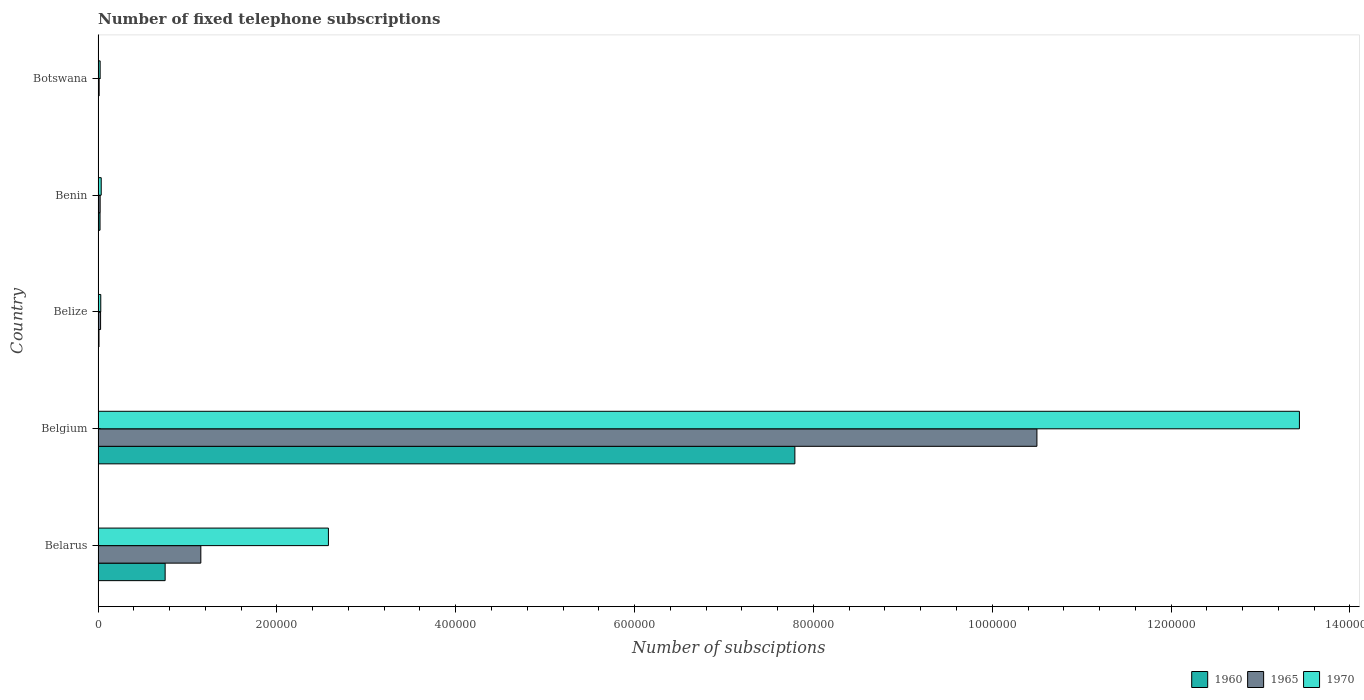What is the label of the 1st group of bars from the top?
Your answer should be very brief. Botswana. In how many cases, is the number of bars for a given country not equal to the number of legend labels?
Make the answer very short. 0. Across all countries, what is the maximum number of fixed telephone subscriptions in 1960?
Offer a very short reply. 7.79e+05. Across all countries, what is the minimum number of fixed telephone subscriptions in 1960?
Make the answer very short. 400. In which country was the number of fixed telephone subscriptions in 1970 minimum?
Give a very brief answer. Botswana. What is the total number of fixed telephone subscriptions in 1960 in the graph?
Give a very brief answer. 8.58e+05. What is the difference between the number of fixed telephone subscriptions in 1965 in Belarus and that in Belize?
Your answer should be very brief. 1.12e+05. What is the average number of fixed telephone subscriptions in 1960 per country?
Provide a succinct answer. 1.72e+05. What is the difference between the number of fixed telephone subscriptions in 1970 and number of fixed telephone subscriptions in 1965 in Belarus?
Your answer should be compact. 1.43e+05. In how many countries, is the number of fixed telephone subscriptions in 1965 greater than 360000 ?
Offer a very short reply. 1. What is the ratio of the number of fixed telephone subscriptions in 1970 in Belgium to that in Botswana?
Ensure brevity in your answer.  584.15. What is the difference between the highest and the second highest number of fixed telephone subscriptions in 1965?
Provide a short and direct response. 9.35e+05. What is the difference between the highest and the lowest number of fixed telephone subscriptions in 1970?
Your answer should be compact. 1.34e+06. Is the sum of the number of fixed telephone subscriptions in 1970 in Belarus and Benin greater than the maximum number of fixed telephone subscriptions in 1965 across all countries?
Keep it short and to the point. No. What does the 1st bar from the bottom in Belarus represents?
Your answer should be very brief. 1960. What is the difference between two consecutive major ticks on the X-axis?
Your answer should be very brief. 2.00e+05. Where does the legend appear in the graph?
Make the answer very short. Bottom right. What is the title of the graph?
Provide a succinct answer. Number of fixed telephone subscriptions. Does "2015" appear as one of the legend labels in the graph?
Offer a very short reply. No. What is the label or title of the X-axis?
Make the answer very short. Number of subsciptions. What is the Number of subsciptions of 1960 in Belarus?
Give a very brief answer. 7.50e+04. What is the Number of subsciptions of 1965 in Belarus?
Make the answer very short. 1.15e+05. What is the Number of subsciptions of 1970 in Belarus?
Keep it short and to the point. 2.58e+05. What is the Number of subsciptions in 1960 in Belgium?
Ensure brevity in your answer.  7.79e+05. What is the Number of subsciptions of 1965 in Belgium?
Provide a succinct answer. 1.05e+06. What is the Number of subsciptions of 1970 in Belgium?
Offer a terse response. 1.34e+06. What is the Number of subsciptions in 1960 in Belize?
Offer a terse response. 1018. What is the Number of subsciptions in 1965 in Belize?
Make the answer very short. 2800. What is the Number of subsciptions in 1970 in Belize?
Keep it short and to the point. 3000. What is the Number of subsciptions of 1960 in Benin?
Your answer should be compact. 2176. What is the Number of subsciptions in 1965 in Benin?
Ensure brevity in your answer.  2300. What is the Number of subsciptions in 1970 in Benin?
Provide a short and direct response. 3500. What is the Number of subsciptions in 1960 in Botswana?
Make the answer very short. 400. What is the Number of subsciptions of 1965 in Botswana?
Keep it short and to the point. 1200. What is the Number of subsciptions in 1970 in Botswana?
Keep it short and to the point. 2300. Across all countries, what is the maximum Number of subsciptions in 1960?
Provide a short and direct response. 7.79e+05. Across all countries, what is the maximum Number of subsciptions in 1965?
Offer a very short reply. 1.05e+06. Across all countries, what is the maximum Number of subsciptions of 1970?
Make the answer very short. 1.34e+06. Across all countries, what is the minimum Number of subsciptions in 1960?
Provide a short and direct response. 400. Across all countries, what is the minimum Number of subsciptions in 1965?
Your answer should be very brief. 1200. Across all countries, what is the minimum Number of subsciptions of 1970?
Give a very brief answer. 2300. What is the total Number of subsciptions in 1960 in the graph?
Offer a very short reply. 8.58e+05. What is the total Number of subsciptions in 1965 in the graph?
Give a very brief answer. 1.17e+06. What is the total Number of subsciptions in 1970 in the graph?
Give a very brief answer. 1.61e+06. What is the difference between the Number of subsciptions in 1960 in Belarus and that in Belgium?
Ensure brevity in your answer.  -7.04e+05. What is the difference between the Number of subsciptions in 1965 in Belarus and that in Belgium?
Offer a terse response. -9.35e+05. What is the difference between the Number of subsciptions of 1970 in Belarus and that in Belgium?
Provide a succinct answer. -1.09e+06. What is the difference between the Number of subsciptions of 1960 in Belarus and that in Belize?
Make the answer very short. 7.40e+04. What is the difference between the Number of subsciptions of 1965 in Belarus and that in Belize?
Your answer should be compact. 1.12e+05. What is the difference between the Number of subsciptions in 1970 in Belarus and that in Belize?
Offer a terse response. 2.55e+05. What is the difference between the Number of subsciptions in 1960 in Belarus and that in Benin?
Provide a short and direct response. 7.28e+04. What is the difference between the Number of subsciptions of 1965 in Belarus and that in Benin?
Your answer should be compact. 1.13e+05. What is the difference between the Number of subsciptions of 1970 in Belarus and that in Benin?
Give a very brief answer. 2.54e+05. What is the difference between the Number of subsciptions in 1960 in Belarus and that in Botswana?
Offer a terse response. 7.46e+04. What is the difference between the Number of subsciptions in 1965 in Belarus and that in Botswana?
Keep it short and to the point. 1.14e+05. What is the difference between the Number of subsciptions in 1970 in Belarus and that in Botswana?
Offer a terse response. 2.55e+05. What is the difference between the Number of subsciptions of 1960 in Belgium and that in Belize?
Make the answer very short. 7.78e+05. What is the difference between the Number of subsciptions in 1965 in Belgium and that in Belize?
Provide a short and direct response. 1.05e+06. What is the difference between the Number of subsciptions in 1970 in Belgium and that in Belize?
Your answer should be compact. 1.34e+06. What is the difference between the Number of subsciptions of 1960 in Belgium and that in Benin?
Your answer should be compact. 7.77e+05. What is the difference between the Number of subsciptions of 1965 in Belgium and that in Benin?
Provide a succinct answer. 1.05e+06. What is the difference between the Number of subsciptions of 1970 in Belgium and that in Benin?
Make the answer very short. 1.34e+06. What is the difference between the Number of subsciptions of 1960 in Belgium and that in Botswana?
Make the answer very short. 7.79e+05. What is the difference between the Number of subsciptions of 1965 in Belgium and that in Botswana?
Your answer should be very brief. 1.05e+06. What is the difference between the Number of subsciptions in 1970 in Belgium and that in Botswana?
Your response must be concise. 1.34e+06. What is the difference between the Number of subsciptions of 1960 in Belize and that in Benin?
Your answer should be very brief. -1158. What is the difference between the Number of subsciptions in 1970 in Belize and that in Benin?
Your answer should be very brief. -500. What is the difference between the Number of subsciptions of 1960 in Belize and that in Botswana?
Make the answer very short. 618. What is the difference between the Number of subsciptions of 1965 in Belize and that in Botswana?
Give a very brief answer. 1600. What is the difference between the Number of subsciptions in 1970 in Belize and that in Botswana?
Provide a succinct answer. 700. What is the difference between the Number of subsciptions of 1960 in Benin and that in Botswana?
Ensure brevity in your answer.  1776. What is the difference between the Number of subsciptions in 1965 in Benin and that in Botswana?
Give a very brief answer. 1100. What is the difference between the Number of subsciptions in 1970 in Benin and that in Botswana?
Your answer should be compact. 1200. What is the difference between the Number of subsciptions in 1960 in Belarus and the Number of subsciptions in 1965 in Belgium?
Provide a succinct answer. -9.75e+05. What is the difference between the Number of subsciptions of 1960 in Belarus and the Number of subsciptions of 1970 in Belgium?
Ensure brevity in your answer.  -1.27e+06. What is the difference between the Number of subsciptions in 1965 in Belarus and the Number of subsciptions in 1970 in Belgium?
Provide a short and direct response. -1.23e+06. What is the difference between the Number of subsciptions in 1960 in Belarus and the Number of subsciptions in 1965 in Belize?
Your response must be concise. 7.22e+04. What is the difference between the Number of subsciptions in 1960 in Belarus and the Number of subsciptions in 1970 in Belize?
Your response must be concise. 7.20e+04. What is the difference between the Number of subsciptions of 1965 in Belarus and the Number of subsciptions of 1970 in Belize?
Provide a succinct answer. 1.12e+05. What is the difference between the Number of subsciptions of 1960 in Belarus and the Number of subsciptions of 1965 in Benin?
Make the answer very short. 7.27e+04. What is the difference between the Number of subsciptions in 1960 in Belarus and the Number of subsciptions in 1970 in Benin?
Offer a very short reply. 7.15e+04. What is the difference between the Number of subsciptions in 1965 in Belarus and the Number of subsciptions in 1970 in Benin?
Ensure brevity in your answer.  1.11e+05. What is the difference between the Number of subsciptions in 1960 in Belarus and the Number of subsciptions in 1965 in Botswana?
Offer a very short reply. 7.38e+04. What is the difference between the Number of subsciptions of 1960 in Belarus and the Number of subsciptions of 1970 in Botswana?
Give a very brief answer. 7.27e+04. What is the difference between the Number of subsciptions in 1965 in Belarus and the Number of subsciptions in 1970 in Botswana?
Make the answer very short. 1.13e+05. What is the difference between the Number of subsciptions in 1960 in Belgium and the Number of subsciptions in 1965 in Belize?
Offer a very short reply. 7.76e+05. What is the difference between the Number of subsciptions of 1960 in Belgium and the Number of subsciptions of 1970 in Belize?
Offer a very short reply. 7.76e+05. What is the difference between the Number of subsciptions of 1965 in Belgium and the Number of subsciptions of 1970 in Belize?
Ensure brevity in your answer.  1.05e+06. What is the difference between the Number of subsciptions of 1960 in Belgium and the Number of subsciptions of 1965 in Benin?
Offer a terse response. 7.77e+05. What is the difference between the Number of subsciptions of 1960 in Belgium and the Number of subsciptions of 1970 in Benin?
Your answer should be compact. 7.76e+05. What is the difference between the Number of subsciptions of 1965 in Belgium and the Number of subsciptions of 1970 in Benin?
Your answer should be compact. 1.05e+06. What is the difference between the Number of subsciptions of 1960 in Belgium and the Number of subsciptions of 1965 in Botswana?
Ensure brevity in your answer.  7.78e+05. What is the difference between the Number of subsciptions in 1960 in Belgium and the Number of subsciptions in 1970 in Botswana?
Keep it short and to the point. 7.77e+05. What is the difference between the Number of subsciptions of 1965 in Belgium and the Number of subsciptions of 1970 in Botswana?
Keep it short and to the point. 1.05e+06. What is the difference between the Number of subsciptions in 1960 in Belize and the Number of subsciptions in 1965 in Benin?
Give a very brief answer. -1282. What is the difference between the Number of subsciptions in 1960 in Belize and the Number of subsciptions in 1970 in Benin?
Offer a terse response. -2482. What is the difference between the Number of subsciptions of 1965 in Belize and the Number of subsciptions of 1970 in Benin?
Your answer should be compact. -700. What is the difference between the Number of subsciptions in 1960 in Belize and the Number of subsciptions in 1965 in Botswana?
Provide a short and direct response. -182. What is the difference between the Number of subsciptions of 1960 in Belize and the Number of subsciptions of 1970 in Botswana?
Your response must be concise. -1282. What is the difference between the Number of subsciptions of 1965 in Belize and the Number of subsciptions of 1970 in Botswana?
Make the answer very short. 500. What is the difference between the Number of subsciptions of 1960 in Benin and the Number of subsciptions of 1965 in Botswana?
Your answer should be very brief. 976. What is the difference between the Number of subsciptions of 1960 in Benin and the Number of subsciptions of 1970 in Botswana?
Make the answer very short. -124. What is the average Number of subsciptions in 1960 per country?
Give a very brief answer. 1.72e+05. What is the average Number of subsciptions of 1965 per country?
Make the answer very short. 2.34e+05. What is the average Number of subsciptions in 1970 per country?
Keep it short and to the point. 3.22e+05. What is the difference between the Number of subsciptions in 1960 and Number of subsciptions in 1965 in Belarus?
Your answer should be compact. -3.99e+04. What is the difference between the Number of subsciptions in 1960 and Number of subsciptions in 1970 in Belarus?
Ensure brevity in your answer.  -1.83e+05. What is the difference between the Number of subsciptions of 1965 and Number of subsciptions of 1970 in Belarus?
Give a very brief answer. -1.43e+05. What is the difference between the Number of subsciptions in 1960 and Number of subsciptions in 1965 in Belgium?
Keep it short and to the point. -2.71e+05. What is the difference between the Number of subsciptions of 1960 and Number of subsciptions of 1970 in Belgium?
Give a very brief answer. -5.64e+05. What is the difference between the Number of subsciptions in 1965 and Number of subsciptions in 1970 in Belgium?
Provide a succinct answer. -2.94e+05. What is the difference between the Number of subsciptions in 1960 and Number of subsciptions in 1965 in Belize?
Make the answer very short. -1782. What is the difference between the Number of subsciptions of 1960 and Number of subsciptions of 1970 in Belize?
Offer a terse response. -1982. What is the difference between the Number of subsciptions in 1965 and Number of subsciptions in 1970 in Belize?
Your answer should be very brief. -200. What is the difference between the Number of subsciptions in 1960 and Number of subsciptions in 1965 in Benin?
Provide a short and direct response. -124. What is the difference between the Number of subsciptions in 1960 and Number of subsciptions in 1970 in Benin?
Your answer should be very brief. -1324. What is the difference between the Number of subsciptions in 1965 and Number of subsciptions in 1970 in Benin?
Your response must be concise. -1200. What is the difference between the Number of subsciptions in 1960 and Number of subsciptions in 1965 in Botswana?
Your response must be concise. -800. What is the difference between the Number of subsciptions in 1960 and Number of subsciptions in 1970 in Botswana?
Offer a terse response. -1900. What is the difference between the Number of subsciptions of 1965 and Number of subsciptions of 1970 in Botswana?
Keep it short and to the point. -1100. What is the ratio of the Number of subsciptions in 1960 in Belarus to that in Belgium?
Your answer should be compact. 0.1. What is the ratio of the Number of subsciptions in 1965 in Belarus to that in Belgium?
Provide a short and direct response. 0.11. What is the ratio of the Number of subsciptions in 1970 in Belarus to that in Belgium?
Your answer should be compact. 0.19. What is the ratio of the Number of subsciptions of 1960 in Belarus to that in Belize?
Make the answer very short. 73.67. What is the ratio of the Number of subsciptions of 1965 in Belarus to that in Belize?
Make the answer very short. 41.04. What is the ratio of the Number of subsciptions of 1970 in Belarus to that in Belize?
Keep it short and to the point. 85.87. What is the ratio of the Number of subsciptions of 1960 in Belarus to that in Benin?
Ensure brevity in your answer.  34.47. What is the ratio of the Number of subsciptions in 1965 in Belarus to that in Benin?
Your response must be concise. 49.96. What is the ratio of the Number of subsciptions in 1970 in Belarus to that in Benin?
Keep it short and to the point. 73.6. What is the ratio of the Number of subsciptions of 1960 in Belarus to that in Botswana?
Ensure brevity in your answer.  187.5. What is the ratio of the Number of subsciptions in 1965 in Belarus to that in Botswana?
Make the answer very short. 95.75. What is the ratio of the Number of subsciptions in 1970 in Belarus to that in Botswana?
Make the answer very short. 112. What is the ratio of the Number of subsciptions of 1960 in Belgium to that in Belize?
Offer a terse response. 765.48. What is the ratio of the Number of subsciptions in 1965 in Belgium to that in Belize?
Give a very brief answer. 374.99. What is the ratio of the Number of subsciptions of 1970 in Belgium to that in Belize?
Your response must be concise. 447.85. What is the ratio of the Number of subsciptions of 1960 in Belgium to that in Benin?
Provide a succinct answer. 358.12. What is the ratio of the Number of subsciptions of 1965 in Belgium to that in Benin?
Offer a terse response. 456.51. What is the ratio of the Number of subsciptions in 1970 in Belgium to that in Benin?
Make the answer very short. 383.87. What is the ratio of the Number of subsciptions of 1960 in Belgium to that in Botswana?
Your answer should be compact. 1948.15. What is the ratio of the Number of subsciptions in 1965 in Belgium to that in Botswana?
Give a very brief answer. 874.98. What is the ratio of the Number of subsciptions of 1970 in Belgium to that in Botswana?
Your answer should be very brief. 584.15. What is the ratio of the Number of subsciptions of 1960 in Belize to that in Benin?
Give a very brief answer. 0.47. What is the ratio of the Number of subsciptions of 1965 in Belize to that in Benin?
Your response must be concise. 1.22. What is the ratio of the Number of subsciptions in 1970 in Belize to that in Benin?
Provide a short and direct response. 0.86. What is the ratio of the Number of subsciptions in 1960 in Belize to that in Botswana?
Ensure brevity in your answer.  2.54. What is the ratio of the Number of subsciptions of 1965 in Belize to that in Botswana?
Your response must be concise. 2.33. What is the ratio of the Number of subsciptions in 1970 in Belize to that in Botswana?
Give a very brief answer. 1.3. What is the ratio of the Number of subsciptions in 1960 in Benin to that in Botswana?
Offer a terse response. 5.44. What is the ratio of the Number of subsciptions of 1965 in Benin to that in Botswana?
Your answer should be very brief. 1.92. What is the ratio of the Number of subsciptions of 1970 in Benin to that in Botswana?
Your answer should be compact. 1.52. What is the difference between the highest and the second highest Number of subsciptions in 1960?
Your answer should be compact. 7.04e+05. What is the difference between the highest and the second highest Number of subsciptions of 1965?
Keep it short and to the point. 9.35e+05. What is the difference between the highest and the second highest Number of subsciptions in 1970?
Your answer should be compact. 1.09e+06. What is the difference between the highest and the lowest Number of subsciptions of 1960?
Provide a short and direct response. 7.79e+05. What is the difference between the highest and the lowest Number of subsciptions in 1965?
Give a very brief answer. 1.05e+06. What is the difference between the highest and the lowest Number of subsciptions in 1970?
Make the answer very short. 1.34e+06. 